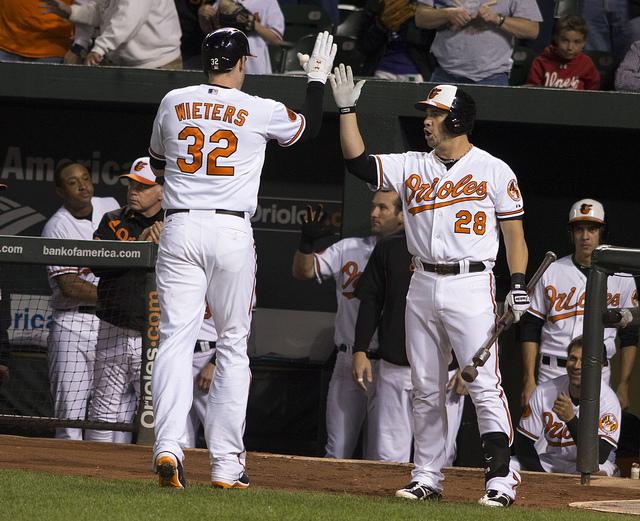What two numbers shown?
Answer briefly. 32 and 28. Are the majority of people on a team on the field?
Give a very brief answer. No. What are the men standing on?
Short answer required. Baseball field. What sport are the men playing?
Write a very short answer. Baseball. 